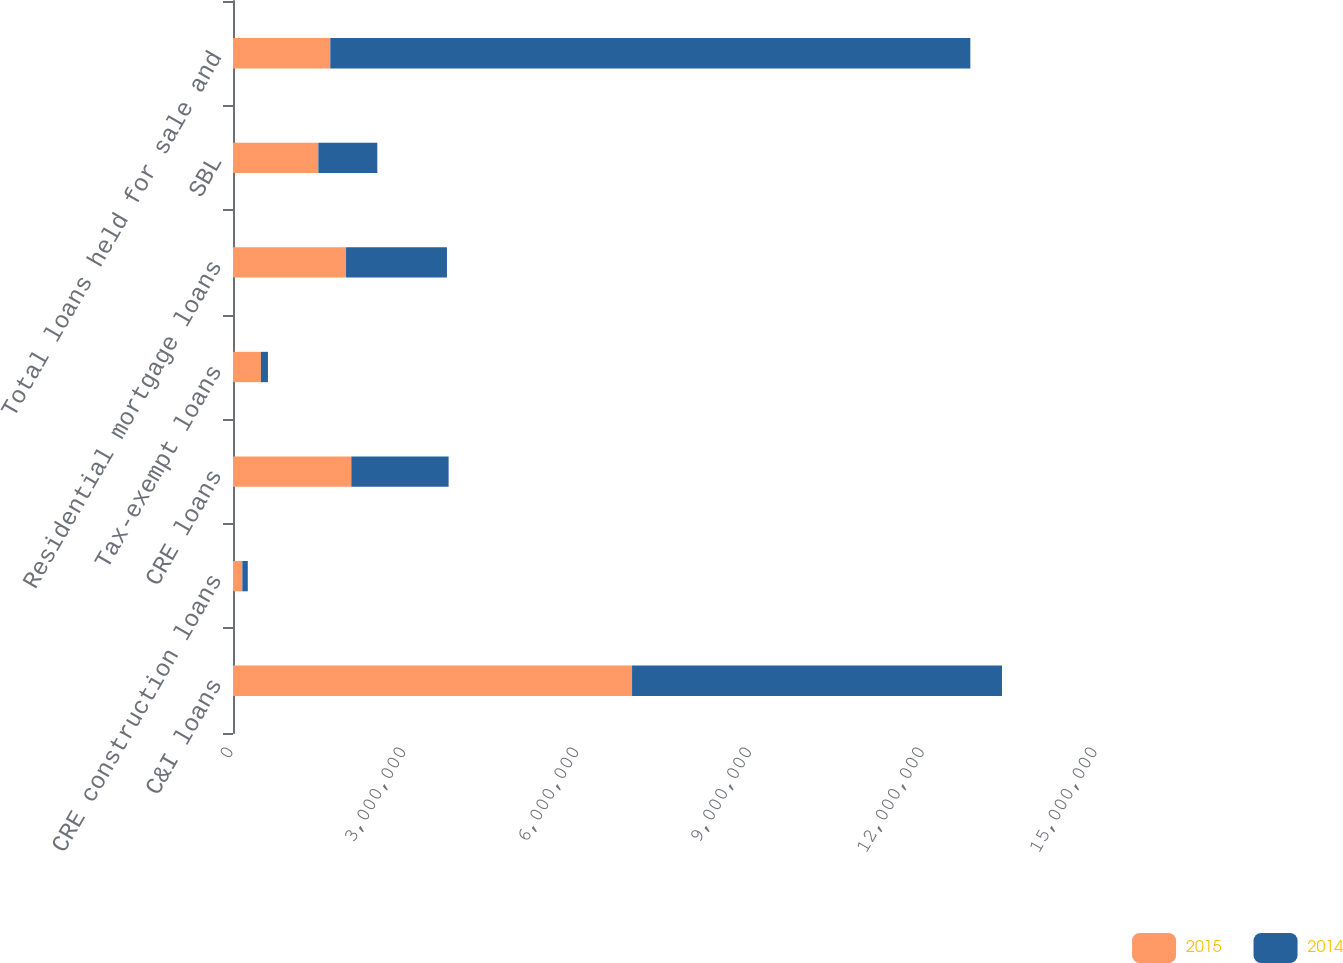<chart> <loc_0><loc_0><loc_500><loc_500><stacked_bar_chart><ecel><fcel>C&I loans<fcel>CRE construction loans<fcel>CRE loans<fcel>Tax-exempt loans<fcel>Residential mortgage loans<fcel>SBL<fcel>Total loans held for sale and<nl><fcel>2015<fcel>6.92802e+06<fcel>162356<fcel>2.05415e+06<fcel>484537<fcel>1.96261e+06<fcel>1.4815e+06<fcel>1.68916e+06<nl><fcel>2014<fcel>6.42235e+06<fcel>94195<fcel>1.68916e+06<fcel>122218<fcel>1.75175e+06<fcel>1.02375e+06<fcel>1.11119e+07<nl></chart> 